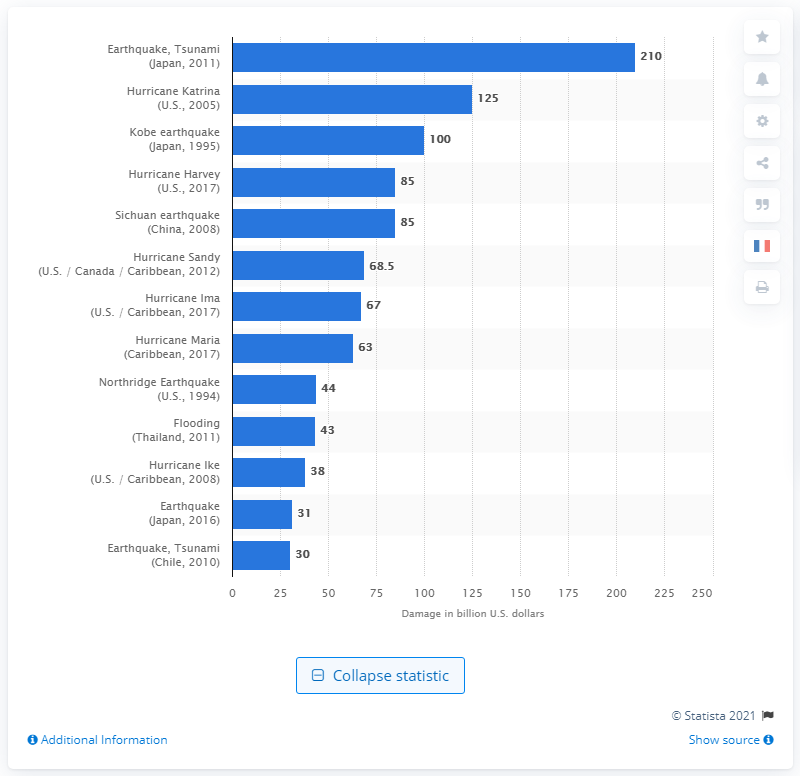Mention a couple of crucial points in this snapshot. The earthquake and tsunami in Japan resulted in significant economic damage, estimated to be approximately 210 billion dollars. 